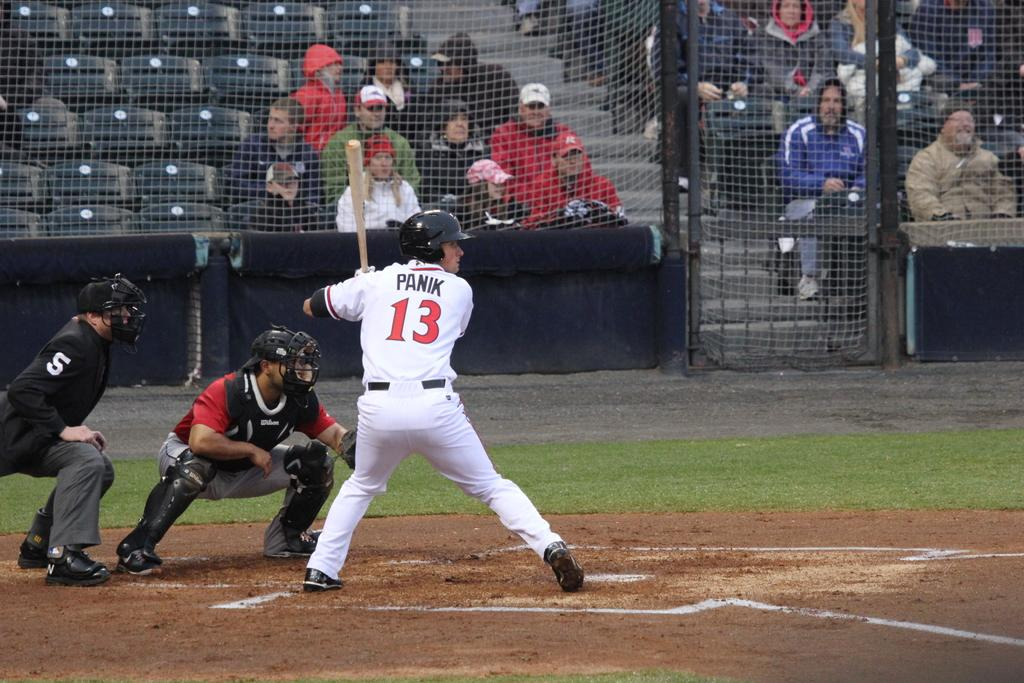Provide a one-sentence caption for the provided image. Panik at the plate getting ready to swing a bat. 